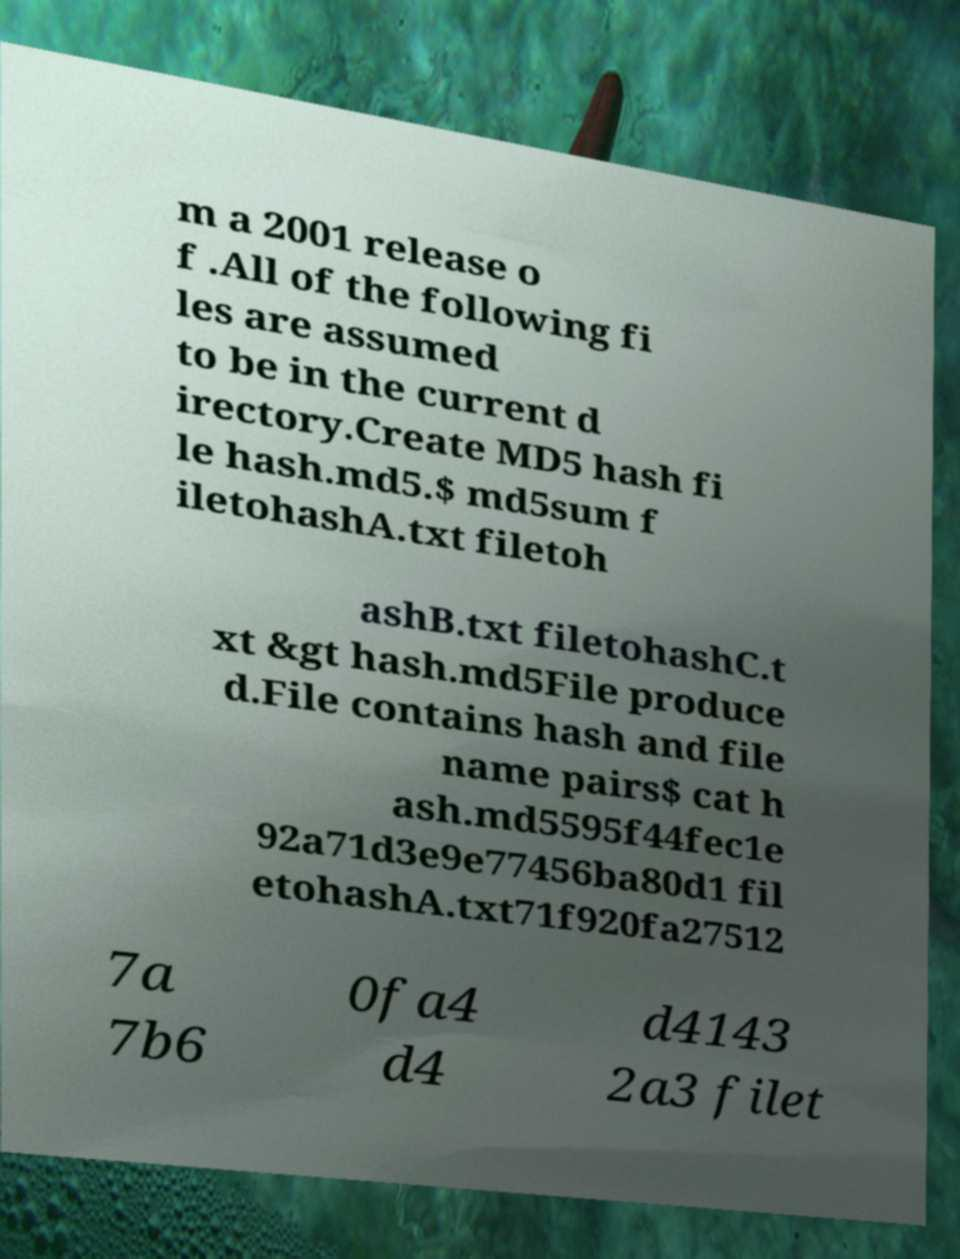For documentation purposes, I need the text within this image transcribed. Could you provide that? m a 2001 release o f .All of the following fi les are assumed to be in the current d irectory.Create MD5 hash fi le hash.md5.$ md5sum f iletohashA.txt filetoh ashB.txt filetohashC.t xt &gt hash.md5File produce d.File contains hash and file name pairs$ cat h ash.md5595f44fec1e 92a71d3e9e77456ba80d1 fil etohashA.txt71f920fa27512 7a 7b6 0fa4 d4 d4143 2a3 filet 